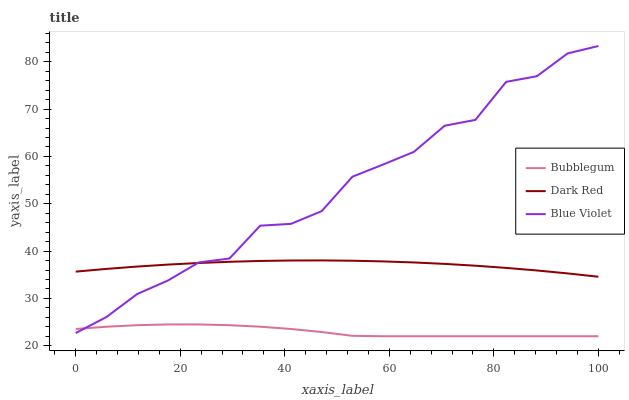Does Bubblegum have the minimum area under the curve?
Answer yes or no. Yes. Does Blue Violet have the maximum area under the curve?
Answer yes or no. Yes. Does Blue Violet have the minimum area under the curve?
Answer yes or no. No. Does Bubblegum have the maximum area under the curve?
Answer yes or no. No. Is Dark Red the smoothest?
Answer yes or no. Yes. Is Blue Violet the roughest?
Answer yes or no. Yes. Is Bubblegum the smoothest?
Answer yes or no. No. Is Bubblegum the roughest?
Answer yes or no. No. Does Bubblegum have the lowest value?
Answer yes or no. Yes. Does Blue Violet have the lowest value?
Answer yes or no. No. Does Blue Violet have the highest value?
Answer yes or no. Yes. Does Bubblegum have the highest value?
Answer yes or no. No. Is Bubblegum less than Dark Red?
Answer yes or no. Yes. Is Dark Red greater than Bubblegum?
Answer yes or no. Yes. Does Blue Violet intersect Dark Red?
Answer yes or no. Yes. Is Blue Violet less than Dark Red?
Answer yes or no. No. Is Blue Violet greater than Dark Red?
Answer yes or no. No. Does Bubblegum intersect Dark Red?
Answer yes or no. No. 